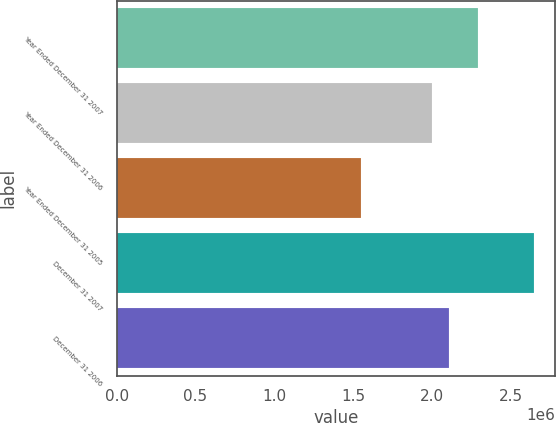<chart> <loc_0><loc_0><loc_500><loc_500><bar_chart><fcel>Year Ended December 31 2007<fcel>Year Ended December 31 2006<fcel>Year Ended December 31 2005<fcel>December 31 2007<fcel>December 31 2006<nl><fcel>2.29119e+06<fcel>1.99874e+06<fcel>1.55244e+06<fcel>2.65055e+06<fcel>2.10855e+06<nl></chart> 